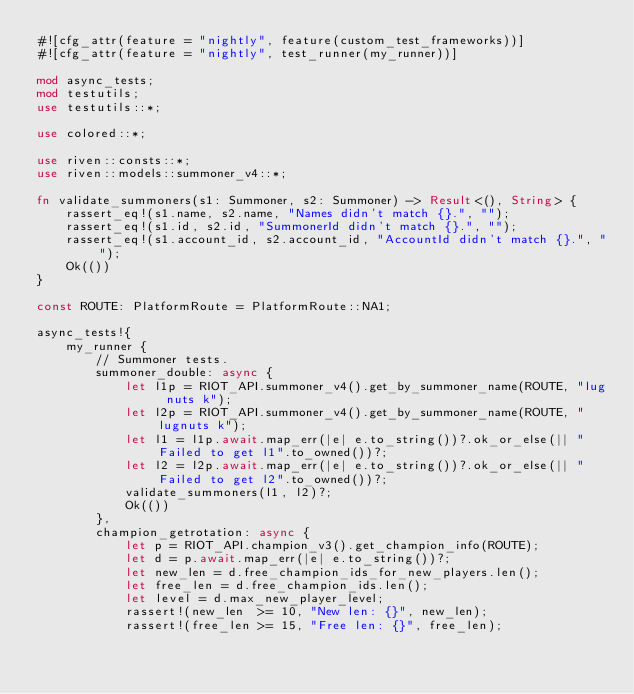Convert code to text. <code><loc_0><loc_0><loc_500><loc_500><_Rust_>#![cfg_attr(feature = "nightly", feature(custom_test_frameworks))]
#![cfg_attr(feature = "nightly", test_runner(my_runner))]

mod async_tests;
mod testutils;
use testutils::*;

use colored::*;

use riven::consts::*;
use riven::models::summoner_v4::*;

fn validate_summoners(s1: Summoner, s2: Summoner) -> Result<(), String> {
    rassert_eq!(s1.name, s2.name, "Names didn't match {}.", "");
    rassert_eq!(s1.id, s2.id, "SummonerId didn't match {}.", "");
    rassert_eq!(s1.account_id, s2.account_id, "AccountId didn't match {}.", "");
    Ok(())
}

const ROUTE: PlatformRoute = PlatformRoute::NA1;

async_tests!{
    my_runner {
        // Summoner tests.
        summoner_double: async {
            let l1p = RIOT_API.summoner_v4().get_by_summoner_name(ROUTE, "lug nuts k");
            let l2p = RIOT_API.summoner_v4().get_by_summoner_name(ROUTE, "lugnuts k");
            let l1 = l1p.await.map_err(|e| e.to_string())?.ok_or_else(|| "Failed to get l1".to_owned())?;
            let l2 = l2p.await.map_err(|e| e.to_string())?.ok_or_else(|| "Failed to get l2".to_owned())?;
            validate_summoners(l1, l2)?;
            Ok(())
        },
        champion_getrotation: async {
            let p = RIOT_API.champion_v3().get_champion_info(ROUTE);
            let d = p.await.map_err(|e| e.to_string())?;
            let new_len = d.free_champion_ids_for_new_players.len();
            let free_len = d.free_champion_ids.len();
            let level = d.max_new_player_level;
            rassert!(new_len  >= 10, "New len: {}", new_len);
            rassert!(free_len >= 15, "Free len: {}", free_len);</code> 